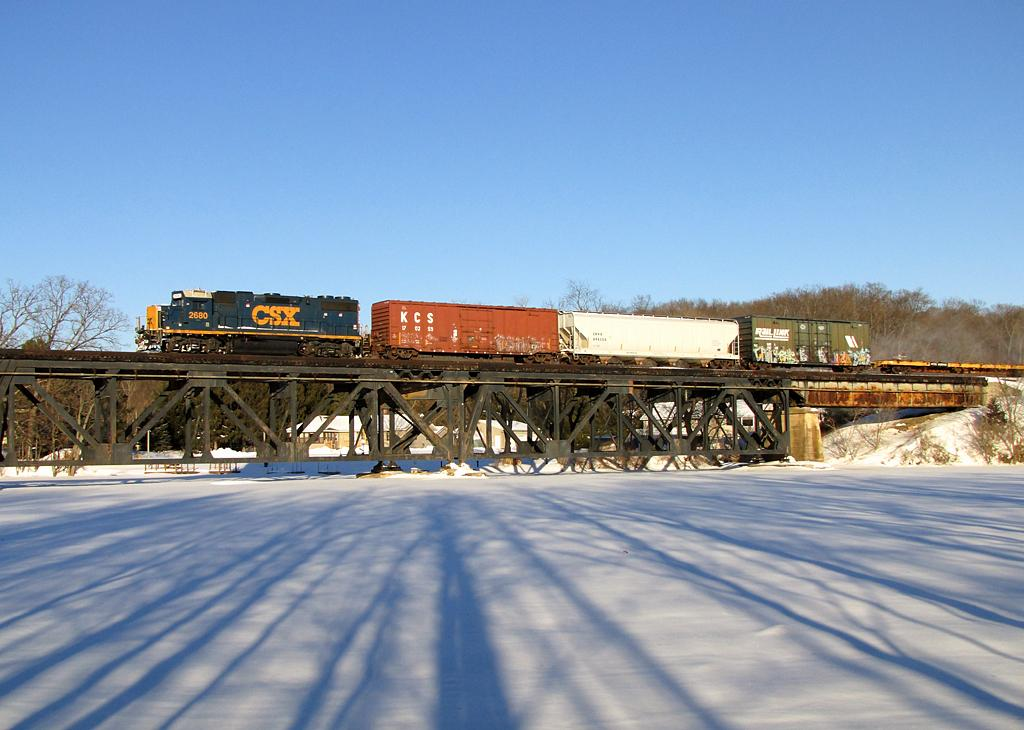<image>
Relay a brief, clear account of the picture shown. A CSX train crosses a bridge over snowy ground beneath. 